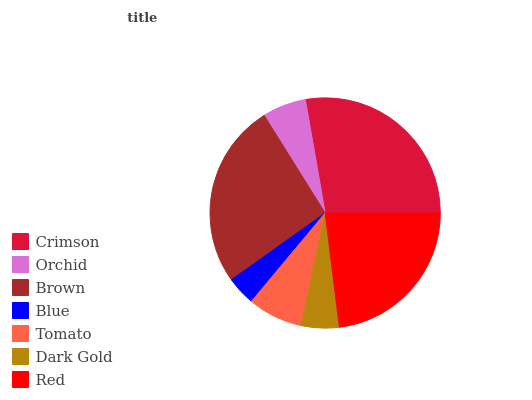Is Blue the minimum?
Answer yes or no. Yes. Is Crimson the maximum?
Answer yes or no. Yes. Is Orchid the minimum?
Answer yes or no. No. Is Orchid the maximum?
Answer yes or no. No. Is Crimson greater than Orchid?
Answer yes or no. Yes. Is Orchid less than Crimson?
Answer yes or no. Yes. Is Orchid greater than Crimson?
Answer yes or no. No. Is Crimson less than Orchid?
Answer yes or no. No. Is Tomato the high median?
Answer yes or no. Yes. Is Tomato the low median?
Answer yes or no. Yes. Is Crimson the high median?
Answer yes or no. No. Is Crimson the low median?
Answer yes or no. No. 